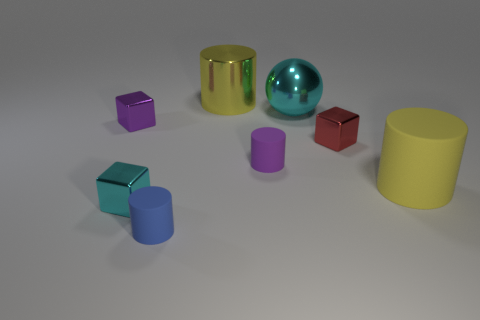Subtract 1 cylinders. How many cylinders are left? 3 Subtract all green cylinders. Subtract all brown balls. How many cylinders are left? 4 Add 1 yellow matte objects. How many objects exist? 9 Subtract all blocks. How many objects are left? 5 Subtract all tiny green shiny cubes. Subtract all big cylinders. How many objects are left? 6 Add 3 blue rubber objects. How many blue rubber objects are left? 4 Add 7 small purple metallic things. How many small purple metallic things exist? 8 Subtract 0 green balls. How many objects are left? 8 